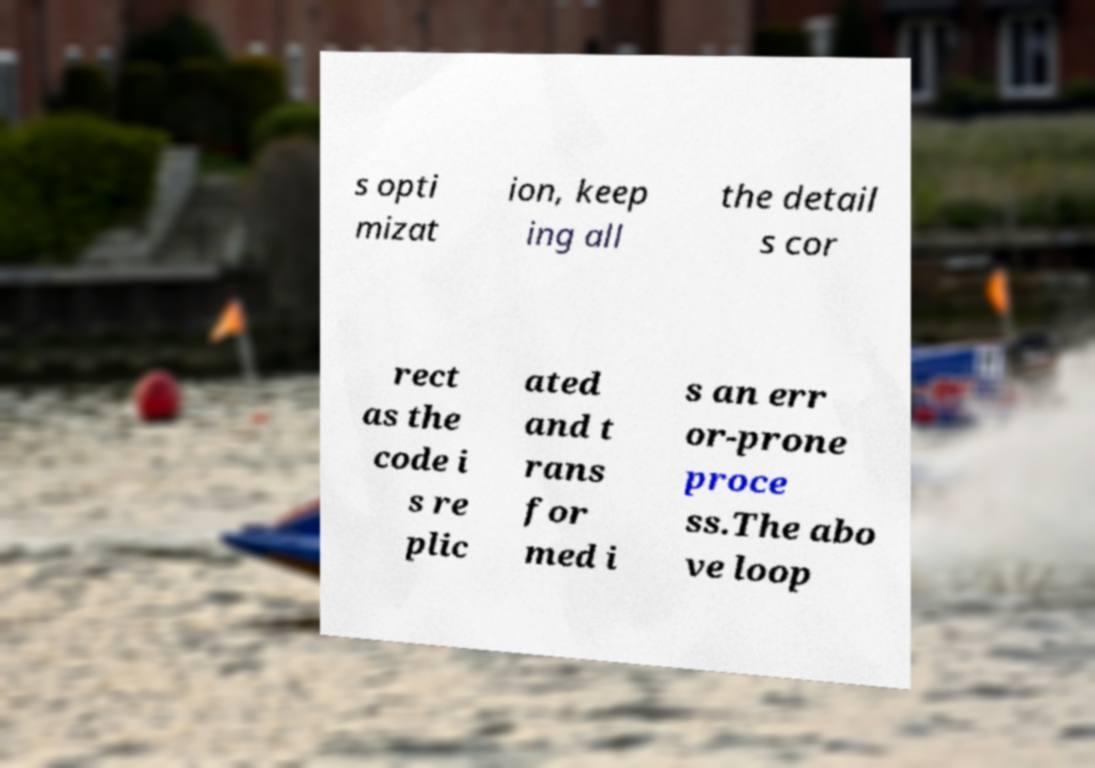Can you accurately transcribe the text from the provided image for me? s opti mizat ion, keep ing all the detail s cor rect as the code i s re plic ated and t rans for med i s an err or-prone proce ss.The abo ve loop 